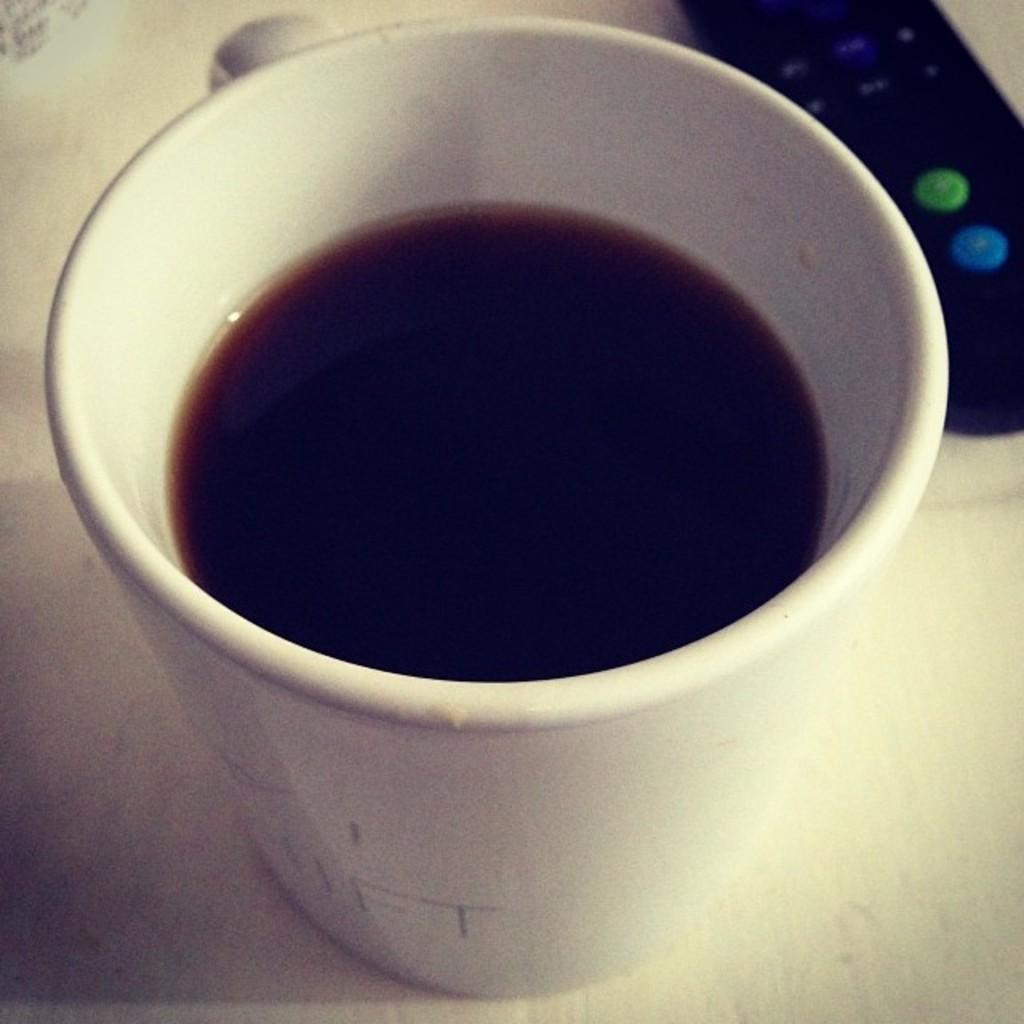Can you describe this image briefly? Here we can see a cup with liquid and a remote on the platform. 